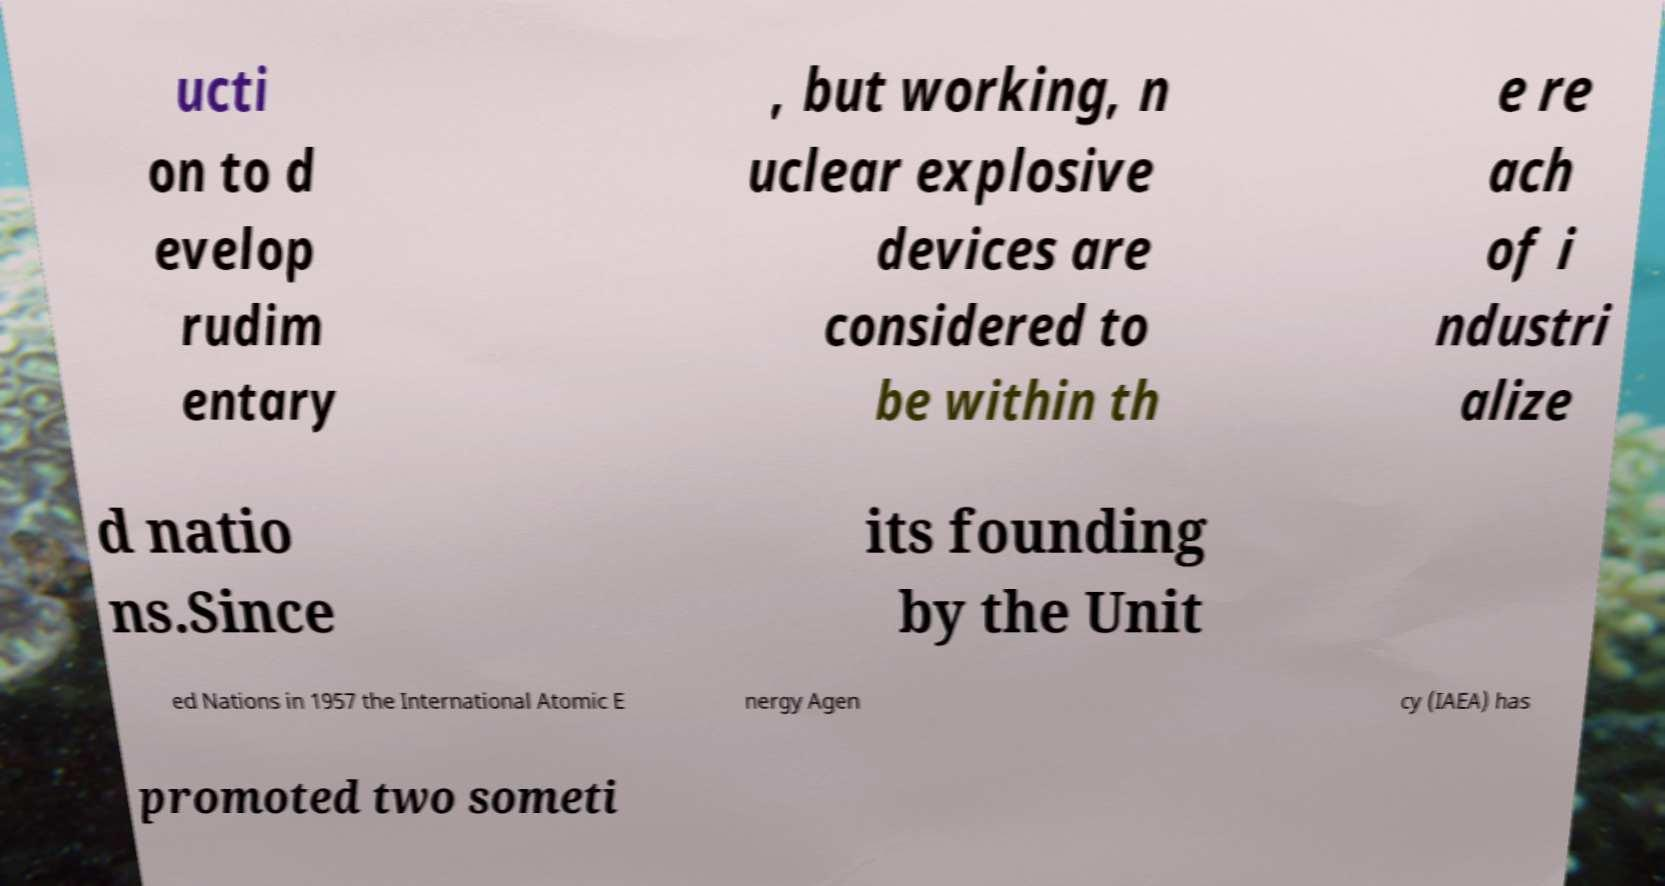Please read and relay the text visible in this image. What does it say? ucti on to d evelop rudim entary , but working, n uclear explosive devices are considered to be within th e re ach of i ndustri alize d natio ns.Since its founding by the Unit ed Nations in 1957 the International Atomic E nergy Agen cy (IAEA) has promoted two someti 